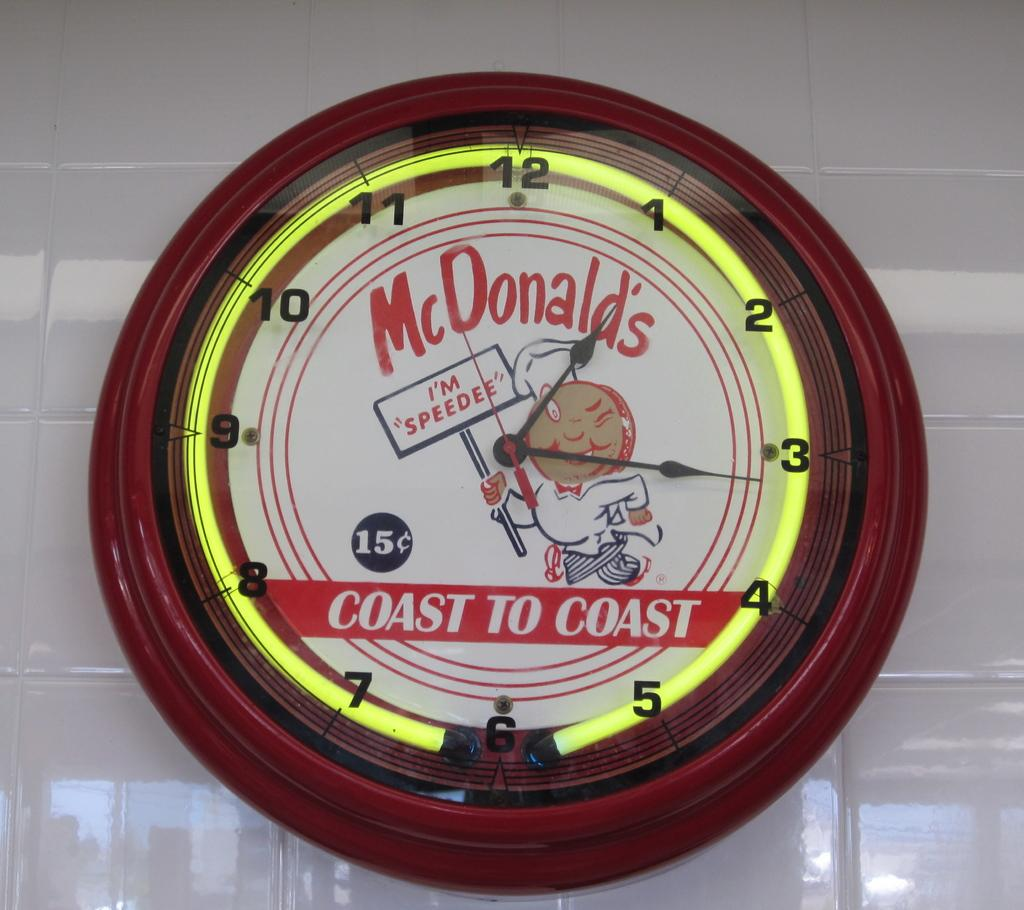Provide a one-sentence caption for the provided image. An old fashioned McDonald;s clock showing the time 1:16. 